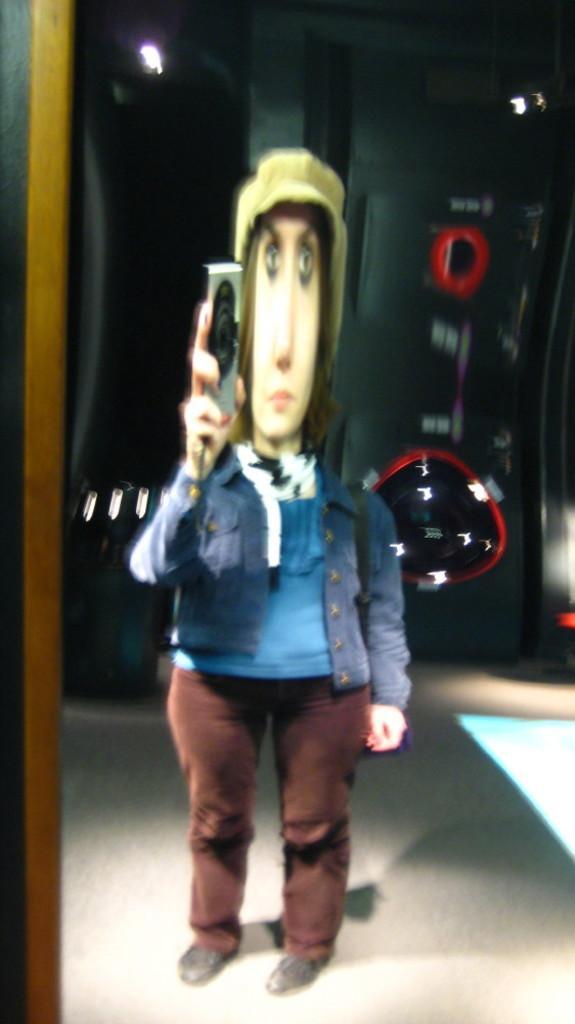Can you describe this image briefly? In this image there is a girl standing on the floor by holding the camera. She is wearing the blue jacket and a scarf. In the background there are speakers. It seems like the face of the girl is big. At the bottom there is light on the right side. 